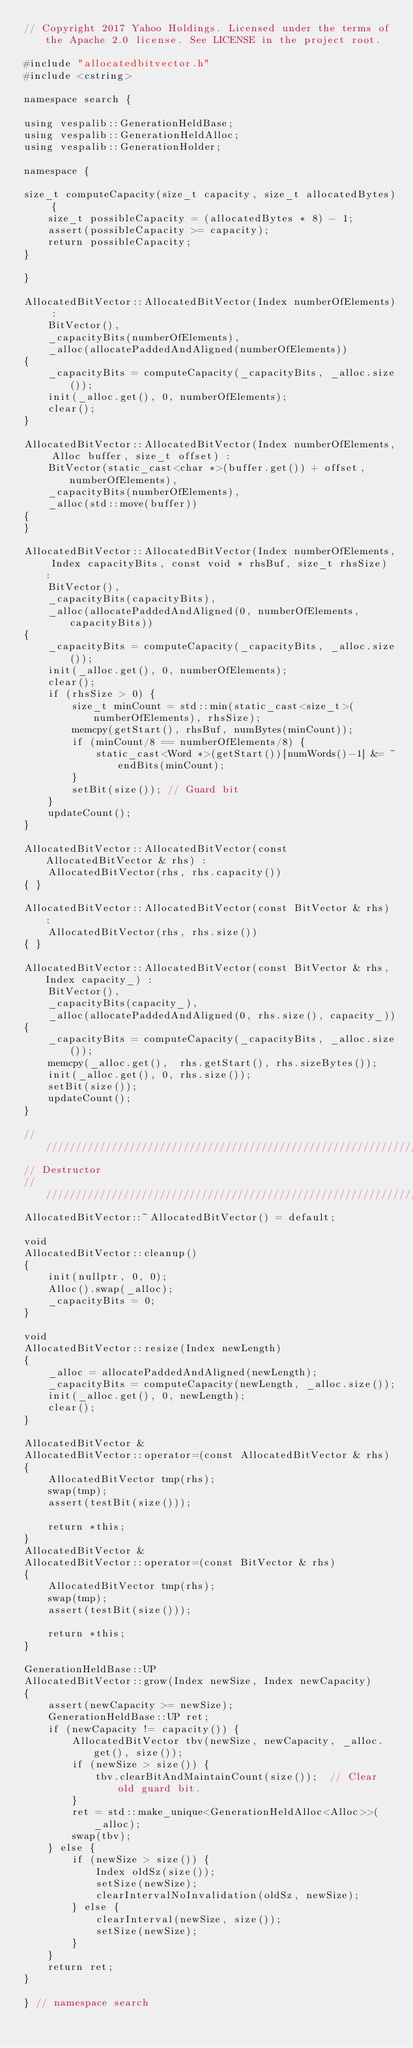<code> <loc_0><loc_0><loc_500><loc_500><_C++_>// Copyright 2017 Yahoo Holdings. Licensed under the terms of the Apache 2.0 license. See LICENSE in the project root.

#include "allocatedbitvector.h"
#include <cstring>

namespace search {

using vespalib::GenerationHeldBase;
using vespalib::GenerationHeldAlloc;
using vespalib::GenerationHolder;

namespace {

size_t computeCapacity(size_t capacity, size_t allocatedBytes) {
    size_t possibleCapacity = (allocatedBytes * 8) - 1;
    assert(possibleCapacity >= capacity);
    return possibleCapacity;
}

}

AllocatedBitVector::AllocatedBitVector(Index numberOfElements) :
    BitVector(),
    _capacityBits(numberOfElements),
    _alloc(allocatePaddedAndAligned(numberOfElements))
{
    _capacityBits = computeCapacity(_capacityBits, _alloc.size());
    init(_alloc.get(), 0, numberOfElements);
    clear();
}

AllocatedBitVector::AllocatedBitVector(Index numberOfElements, Alloc buffer, size_t offset) :
    BitVector(static_cast<char *>(buffer.get()) + offset, numberOfElements),
    _capacityBits(numberOfElements),
    _alloc(std::move(buffer))
{
}

AllocatedBitVector::AllocatedBitVector(Index numberOfElements, Index capacityBits, const void * rhsBuf, size_t rhsSize) :
    BitVector(),
    _capacityBits(capacityBits),
    _alloc(allocatePaddedAndAligned(0, numberOfElements, capacityBits))
{
    _capacityBits = computeCapacity(_capacityBits, _alloc.size());
    init(_alloc.get(), 0, numberOfElements);
    clear();
    if (rhsSize > 0) {
        size_t minCount = std::min(static_cast<size_t>(numberOfElements), rhsSize);
        memcpy(getStart(), rhsBuf, numBytes(minCount));
        if (minCount/8 == numberOfElements/8) {
            static_cast<Word *>(getStart())[numWords()-1] &= ~endBits(minCount);
        }
        setBit(size()); // Guard bit
    }
    updateCount();
}

AllocatedBitVector::AllocatedBitVector(const AllocatedBitVector & rhs) :
    AllocatedBitVector(rhs, rhs.capacity())
{ }

AllocatedBitVector::AllocatedBitVector(const BitVector & rhs) :
    AllocatedBitVector(rhs, rhs.size())
{ }

AllocatedBitVector::AllocatedBitVector(const BitVector & rhs, Index capacity_) :
    BitVector(),
    _capacityBits(capacity_),
    _alloc(allocatePaddedAndAligned(0, rhs.size(), capacity_))
{
    _capacityBits = computeCapacity(_capacityBits, _alloc.size());
    memcpy(_alloc.get(),  rhs.getStart(), rhs.sizeBytes());
    init(_alloc.get(), 0, rhs.size());
    setBit(size());
    updateCount();
}

//////////////////////////////////////////////////////////////////////
// Destructor
//////////////////////////////////////////////////////////////////////
AllocatedBitVector::~AllocatedBitVector() = default;

void
AllocatedBitVector::cleanup()
{
    init(nullptr, 0, 0);
    Alloc().swap(_alloc);
    _capacityBits = 0;
}

void
AllocatedBitVector::resize(Index newLength)
{
    _alloc = allocatePaddedAndAligned(newLength);
    _capacityBits = computeCapacity(newLength, _alloc.size());
    init(_alloc.get(), 0, newLength);
    clear();
}

AllocatedBitVector &
AllocatedBitVector::operator=(const AllocatedBitVector & rhs)
{
    AllocatedBitVector tmp(rhs);
    swap(tmp);
    assert(testBit(size()));

    return *this;
}
AllocatedBitVector &
AllocatedBitVector::operator=(const BitVector & rhs)
{
    AllocatedBitVector tmp(rhs);
    swap(tmp);
    assert(testBit(size()));

    return *this;
}

GenerationHeldBase::UP
AllocatedBitVector::grow(Index newSize, Index newCapacity)
{
    assert(newCapacity >= newSize);
    GenerationHeldBase::UP ret;
    if (newCapacity != capacity()) {
        AllocatedBitVector tbv(newSize, newCapacity, _alloc.get(), size());
        if (newSize > size()) {
            tbv.clearBitAndMaintainCount(size());  // Clear old guard bit.
        }
        ret = std::make_unique<GenerationHeldAlloc<Alloc>>(_alloc);
        swap(tbv);
    } else {
        if (newSize > size()) {
            Index oldSz(size());
            setSize(newSize);
            clearIntervalNoInvalidation(oldSz, newSize);
        } else {
            clearInterval(newSize, size());
            setSize(newSize);
        }
    }
    return ret;
}

} // namespace search
</code> 